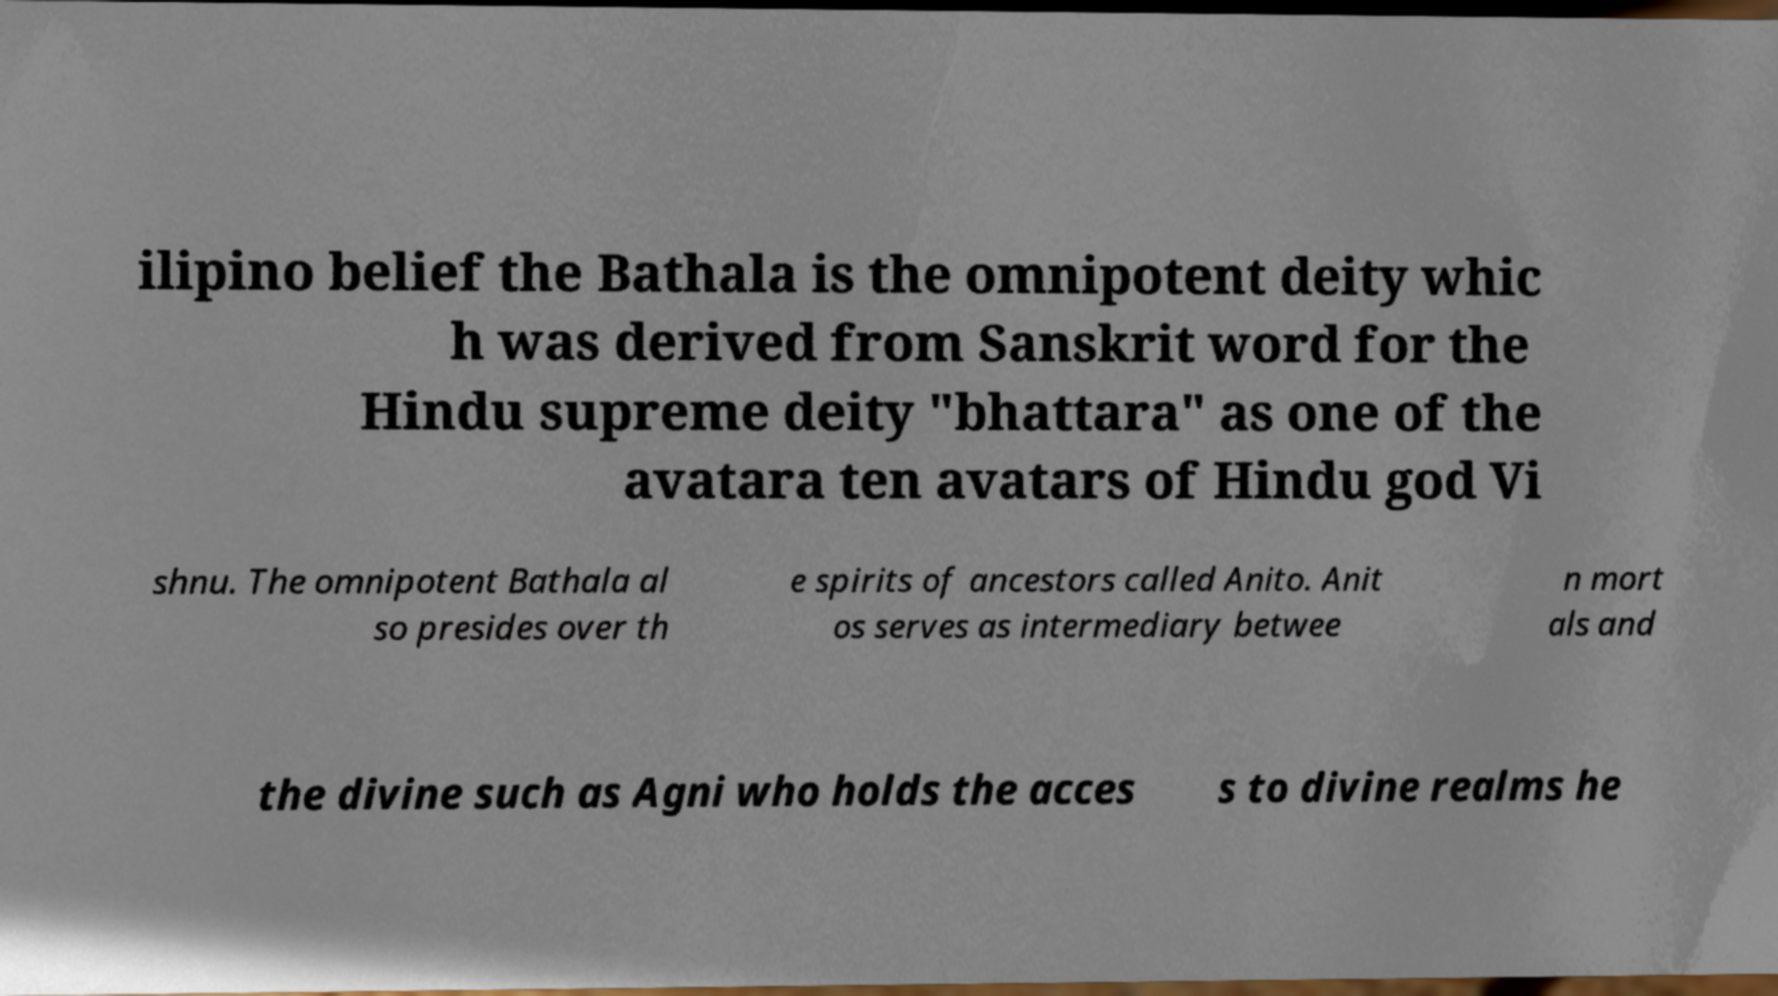Please identify and transcribe the text found in this image. ilipino belief the Bathala is the omnipotent deity whic h was derived from Sanskrit word for the Hindu supreme deity "bhattara" as one of the avatara ten avatars of Hindu god Vi shnu. The omnipotent Bathala al so presides over th e spirits of ancestors called Anito. Anit os serves as intermediary betwee n mort als and the divine such as Agni who holds the acces s to divine realms he 